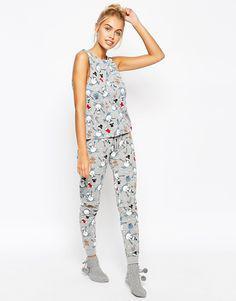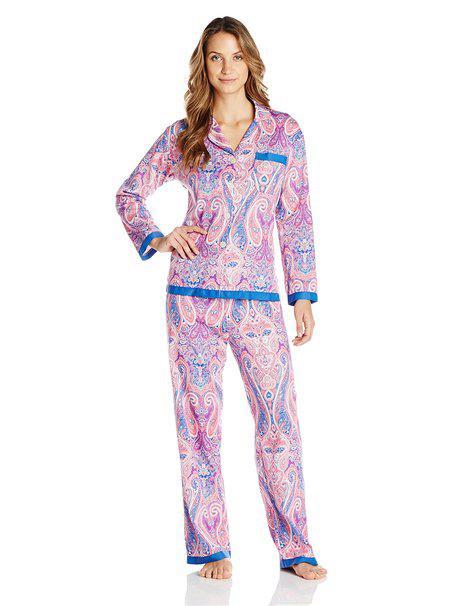The first image is the image on the left, the second image is the image on the right. Analyze the images presented: Is the assertion "Right image shows one model in pajamas with solid trim at the hems." valid? Answer yes or no. Yes. The first image is the image on the left, the second image is the image on the right. Given the left and right images, does the statement "A pajama shirt in one image has solid contrasting trim on the shirt's bottom hem, pocket, and sleeve cuffs." hold true? Answer yes or no. Yes. 